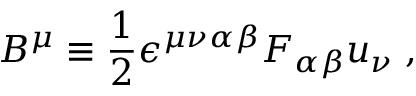<formula> <loc_0><loc_0><loc_500><loc_500>B ^ { \mu } \equiv \frac { 1 } { 2 } \epsilon ^ { \mu \nu \alpha \beta } F _ { \alpha \beta } u _ { \nu } \, ,</formula> 